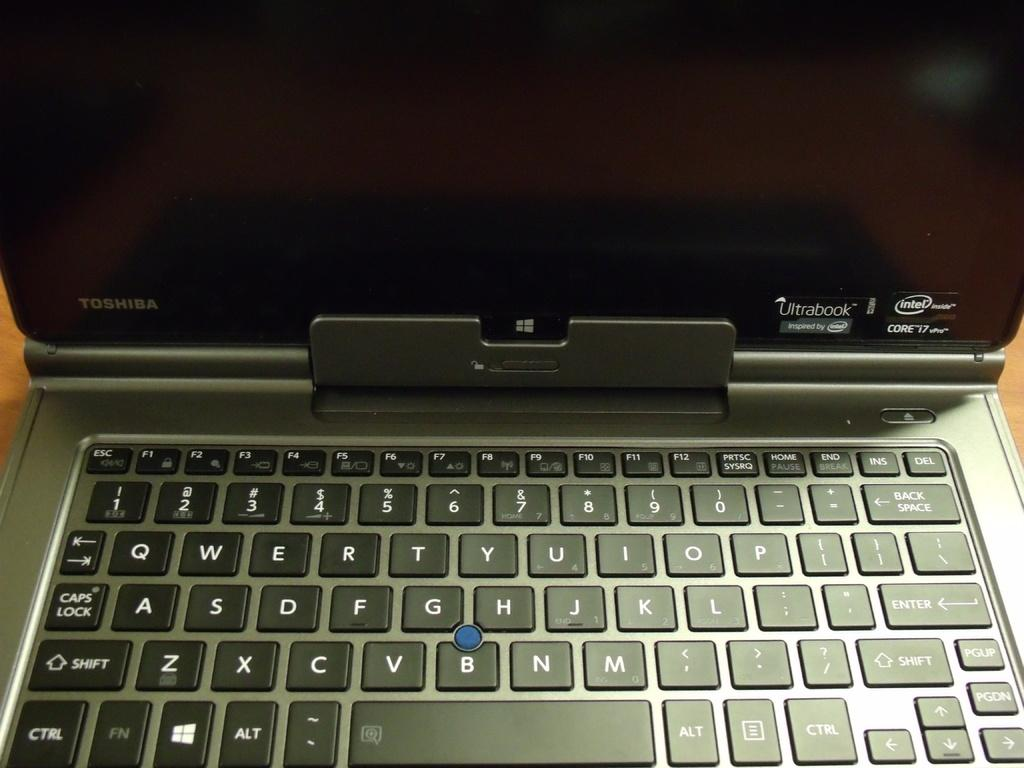<image>
Present a compact description of the photo's key features. A laptop is open and has a sticker that says Ultrabook on the screen. 